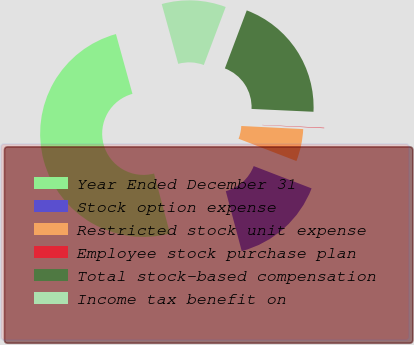<chart> <loc_0><loc_0><loc_500><loc_500><pie_chart><fcel>Year Ended December 31<fcel>Stock option expense<fcel>Restricted stock unit expense<fcel>Employee stock purchase plan<fcel>Total stock-based compensation<fcel>Income tax benefit on<nl><fcel>49.85%<fcel>15.01%<fcel>5.05%<fcel>0.07%<fcel>19.99%<fcel>10.03%<nl></chart> 